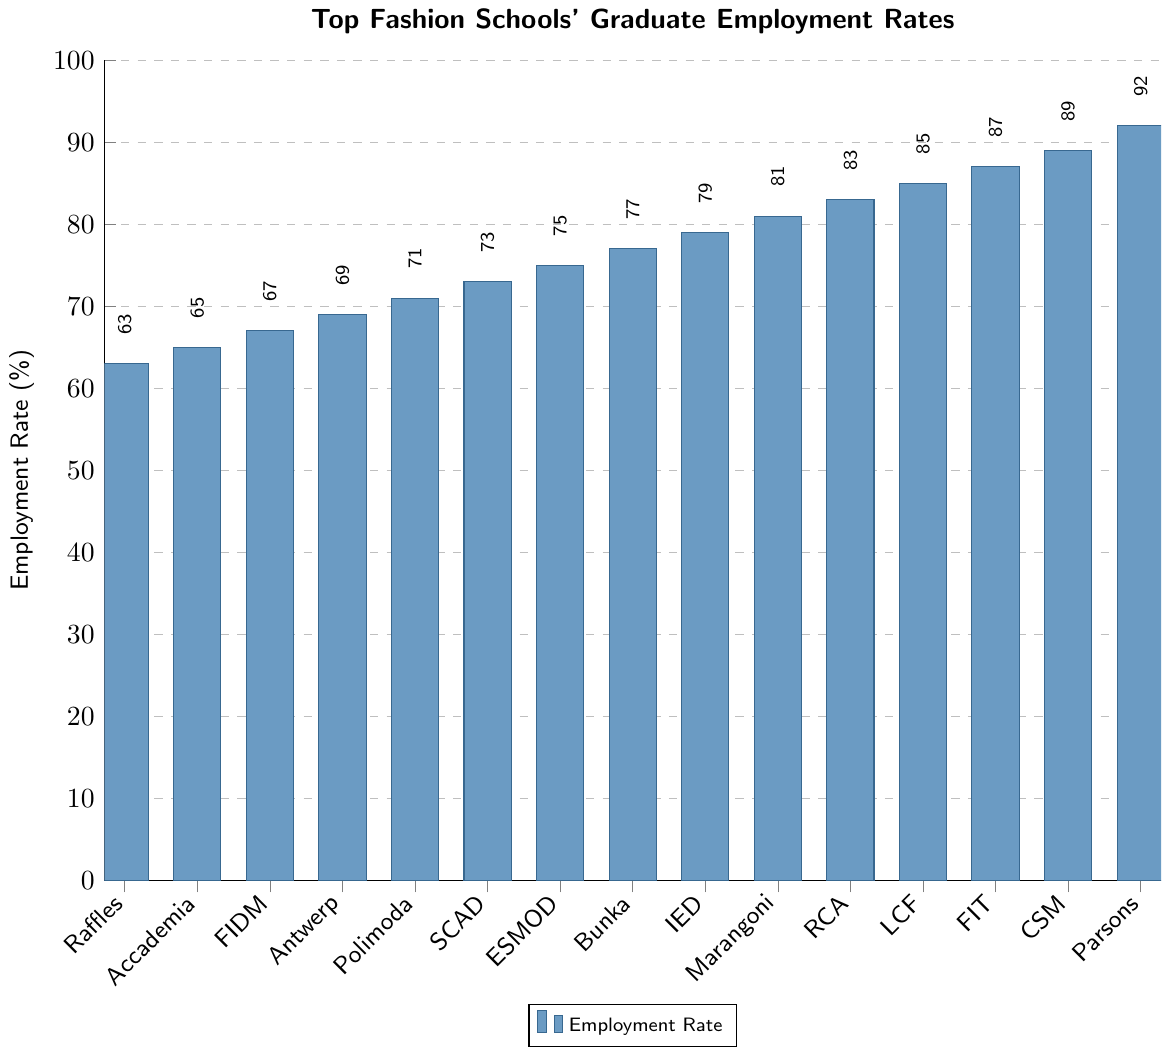Which school has the highest graduate employment rate? Identify the school with the tallest bar on the chart. Parsons School of Design has the tallest bar, indicating it has the highest employment rate.
Answer: Parsons School of Design Which school has the lowest graduate employment rate? Look for the school with the shortest bar on the chart. The Raffles Design Institute has the shortest bar, indicating it has the lowest employment rate.
Answer: Raffles Design Institute What is the difference in employment rates between Central Saint Martins and Fashion Institute of Design & Merchandising? Find the height of the bars for both schools and subtract the employment rate for Fashion Institute of Design & Merchandising from Central Saint Martins. Central Saint Martins is 89% and Fashion Institute of Design & Merchandising is 67%, so 89% - 67% = 22%.
Answer: 22% Which schools have employment rates above 80%? Identify the bars that exceed the 80% line and list the corresponding schools. These are Parsons School of Design, Central Saint Martins, Fashion Institute of Technology, London College of Fashion, Royal College of Art, and Instituto Marangoni.
Answer: Parsons, Central Saint Martins, Fashion Institute of Technology, London College of Fashion, Royal College of Art, Instituto Marangoni What is the average employment rate of Bunka Fashion College, ESMOD International, and Savannah College of Art and Design? Add the employment rates of these three schools and divide by the number of schools. Bunka (77%) + ESMOD (75%) + SCAD (73%) = 225%, then 225% / 3 = 75%.
Answer: 75% Is the employment rate of Instituto Europeo di Design closer to that of Royal College of Art or Bunka Fashion College? Compare the difference between IED and RCA, and IED and Bunka. IED is 79%, RCA is 83%, and Bunka is 77%. (83-79 = 4), (79-77 = 2). 2 is less than 4, so IED is closer to Bunka.
Answer: Bunka Fashion College Which two schools have the closest employment rates? Identify the pair of schools with the smallest difference in employment rates. Accademia Costume & Moda (65%) and Fashion Institute of Design & Merchandising (67%) have a difference of 2%.
Answer: Accademia Costume & Moda and Fashion Institute of Design & Merchandising Rank the top three schools by their graduate employment rates. List the schools in descending order based on their bar heights. The top three are Parsons School of Design (92%), Central Saint Martins (89%), and Fashion Institute of Technology (87%).
Answer: Parsons, Central Saint Martins, Fashion Institute of Technology If you combine the employment rates of the bottom three schools, what is the total? Add the employment rates of the bottom three schools. Raffles (63%), Accademia (65%), and FIDM (67%). 63 + 65 + 67 = 195%.
Answer: 195% What percentage of the schools have employment rates above 75%? Count the number of schools with employment rates above 75% and divide by the total number of schools, then multiply by 100. Eight schools (Parsons, Central Saint Martins, Fashion Institute of Technology, London College of Fashion, Royal College of Art, Instituto Marangoni, Istituto Europeo di Design, and Bunka) out of fifteen schools have rates above 75%. (8/15) * 100 = ~53.33%.
Answer: ~53.33% 